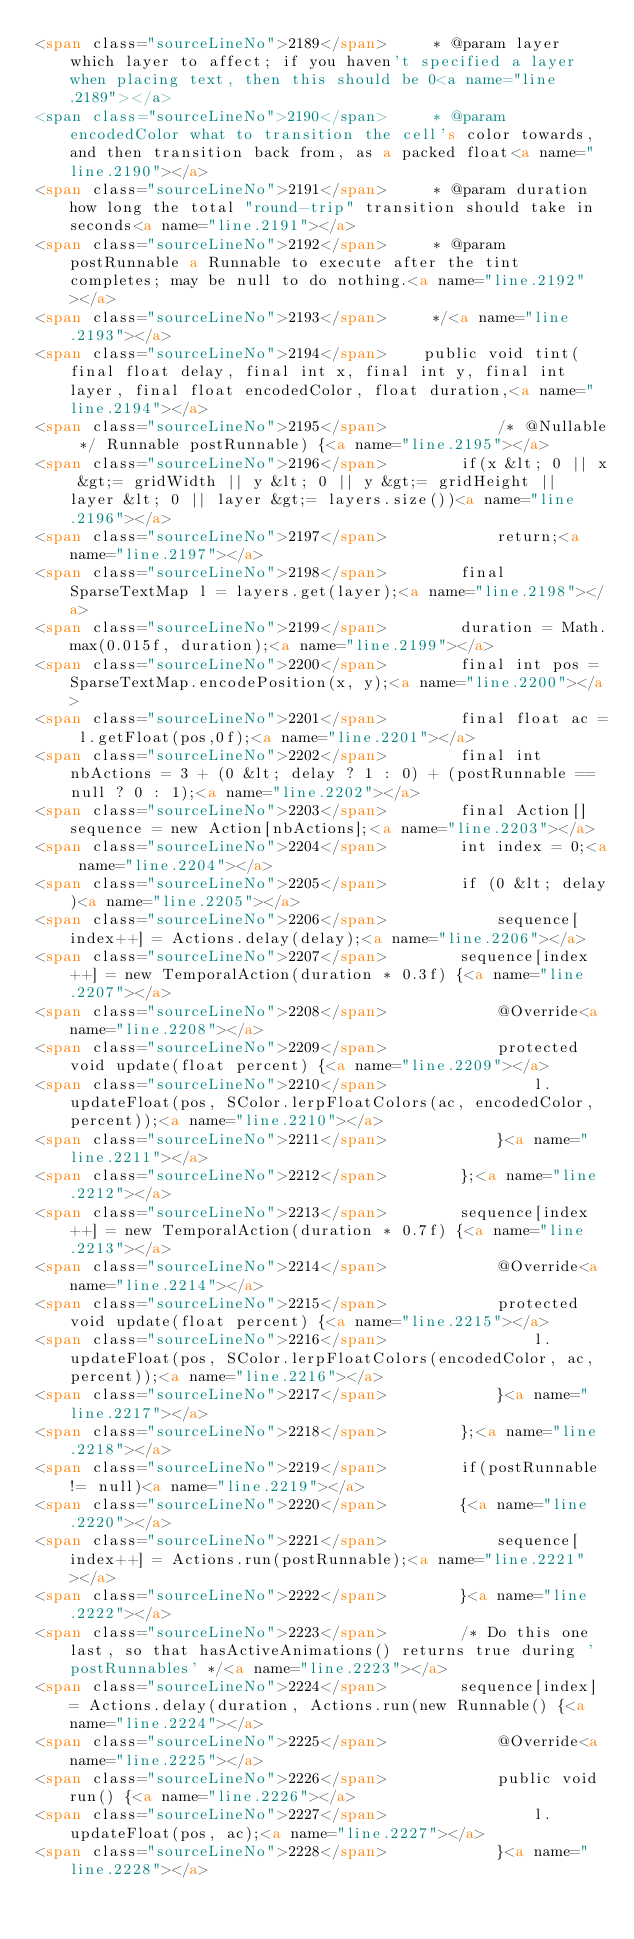<code> <loc_0><loc_0><loc_500><loc_500><_HTML_><span class="sourceLineNo">2189</span>     * @param layer which layer to affect; if you haven't specified a layer when placing text, then this should be 0<a name="line.2189"></a>
<span class="sourceLineNo">2190</span>     * @param encodedColor what to transition the cell's color towards, and then transition back from, as a packed float<a name="line.2190"></a>
<span class="sourceLineNo">2191</span>     * @param duration how long the total "round-trip" transition should take in seconds<a name="line.2191"></a>
<span class="sourceLineNo">2192</span>     * @param postRunnable a Runnable to execute after the tint completes; may be null to do nothing.<a name="line.2192"></a>
<span class="sourceLineNo">2193</span>     */<a name="line.2193"></a>
<span class="sourceLineNo">2194</span>    public void tint(final float delay, final int x, final int y, final int layer, final float encodedColor, float duration,<a name="line.2194"></a>
<span class="sourceLineNo">2195</span>            /* @Nullable */ Runnable postRunnable) {<a name="line.2195"></a>
<span class="sourceLineNo">2196</span>        if(x &lt; 0 || x &gt;= gridWidth || y &lt; 0 || y &gt;= gridHeight || layer &lt; 0 || layer &gt;= layers.size())<a name="line.2196"></a>
<span class="sourceLineNo">2197</span>            return;<a name="line.2197"></a>
<span class="sourceLineNo">2198</span>        final SparseTextMap l = layers.get(layer);<a name="line.2198"></a>
<span class="sourceLineNo">2199</span>        duration = Math.max(0.015f, duration);<a name="line.2199"></a>
<span class="sourceLineNo">2200</span>        final int pos = SparseTextMap.encodePosition(x, y);<a name="line.2200"></a>
<span class="sourceLineNo">2201</span>        final float ac = l.getFloat(pos,0f);<a name="line.2201"></a>
<span class="sourceLineNo">2202</span>        final int nbActions = 3 + (0 &lt; delay ? 1 : 0) + (postRunnable == null ? 0 : 1);<a name="line.2202"></a>
<span class="sourceLineNo">2203</span>        final Action[] sequence = new Action[nbActions];<a name="line.2203"></a>
<span class="sourceLineNo">2204</span>        int index = 0;<a name="line.2204"></a>
<span class="sourceLineNo">2205</span>        if (0 &lt; delay)<a name="line.2205"></a>
<span class="sourceLineNo">2206</span>            sequence[index++] = Actions.delay(delay);<a name="line.2206"></a>
<span class="sourceLineNo">2207</span>        sequence[index++] = new TemporalAction(duration * 0.3f) {<a name="line.2207"></a>
<span class="sourceLineNo">2208</span>            @Override<a name="line.2208"></a>
<span class="sourceLineNo">2209</span>            protected void update(float percent) {<a name="line.2209"></a>
<span class="sourceLineNo">2210</span>                l.updateFloat(pos, SColor.lerpFloatColors(ac, encodedColor, percent));<a name="line.2210"></a>
<span class="sourceLineNo">2211</span>            }<a name="line.2211"></a>
<span class="sourceLineNo">2212</span>        };<a name="line.2212"></a>
<span class="sourceLineNo">2213</span>        sequence[index++] = new TemporalAction(duration * 0.7f) {<a name="line.2213"></a>
<span class="sourceLineNo">2214</span>            @Override<a name="line.2214"></a>
<span class="sourceLineNo">2215</span>            protected void update(float percent) {<a name="line.2215"></a>
<span class="sourceLineNo">2216</span>                l.updateFloat(pos, SColor.lerpFloatColors(encodedColor, ac, percent));<a name="line.2216"></a>
<span class="sourceLineNo">2217</span>            }<a name="line.2217"></a>
<span class="sourceLineNo">2218</span>        };<a name="line.2218"></a>
<span class="sourceLineNo">2219</span>        if(postRunnable != null)<a name="line.2219"></a>
<span class="sourceLineNo">2220</span>        {<a name="line.2220"></a>
<span class="sourceLineNo">2221</span>            sequence[index++] = Actions.run(postRunnable);<a name="line.2221"></a>
<span class="sourceLineNo">2222</span>        }<a name="line.2222"></a>
<span class="sourceLineNo">2223</span>        /* Do this one last, so that hasActiveAnimations() returns true during 'postRunnables' */<a name="line.2223"></a>
<span class="sourceLineNo">2224</span>        sequence[index] = Actions.delay(duration, Actions.run(new Runnable() {<a name="line.2224"></a>
<span class="sourceLineNo">2225</span>            @Override<a name="line.2225"></a>
<span class="sourceLineNo">2226</span>            public void run() {<a name="line.2226"></a>
<span class="sourceLineNo">2227</span>                l.updateFloat(pos, ac);<a name="line.2227"></a>
<span class="sourceLineNo">2228</span>            }<a name="line.2228"></a></code> 